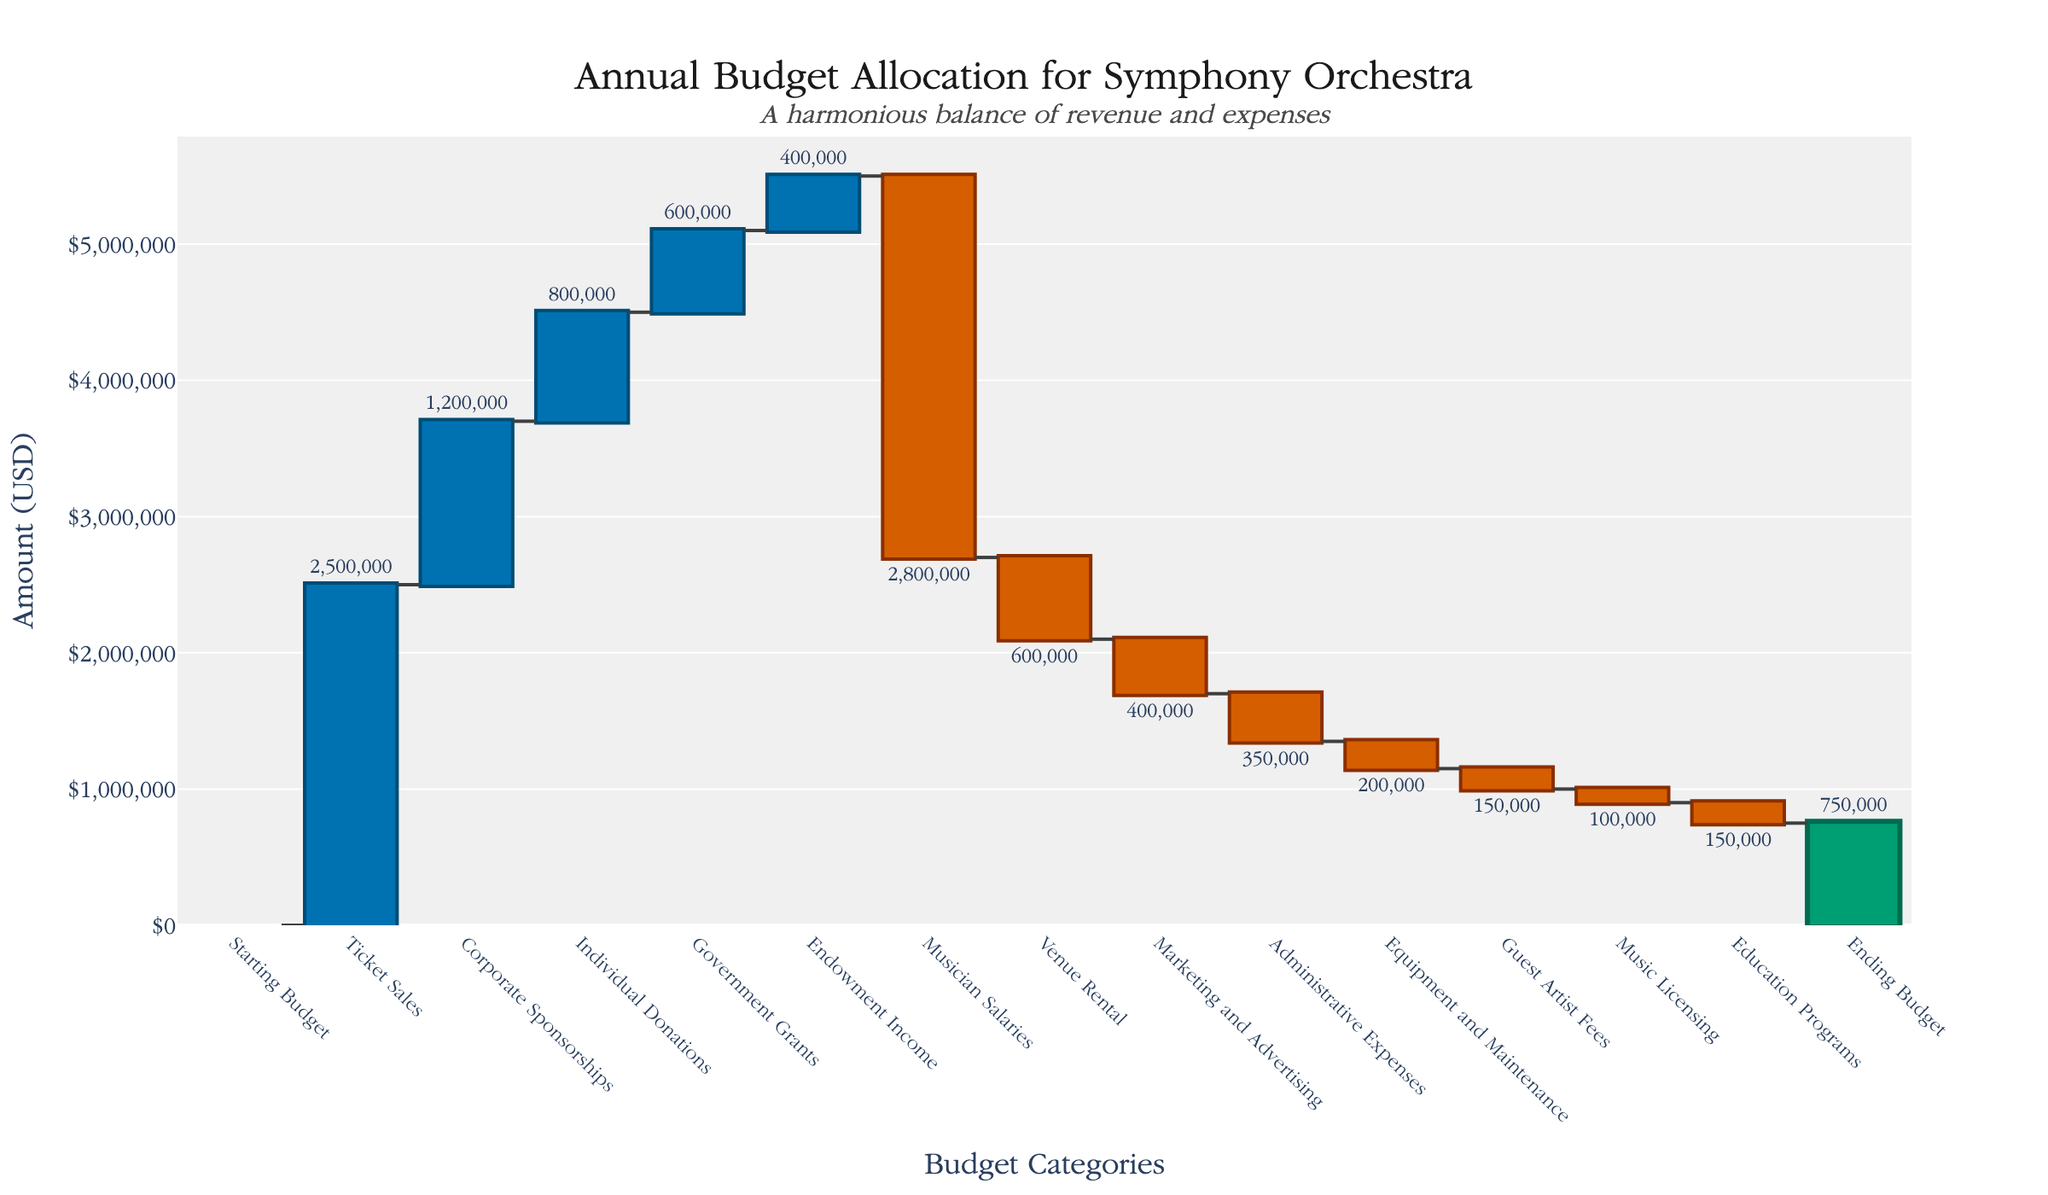What's the title of the figure? The title is prominently placed at the top of the figure, centered, and states "Annual Budget Allocation for Symphony Orchestra".
Answer: Annual Budget Allocation for Symphony Orchestra What is the value of the ending budget? Find the "Ending Budget" bar towards the end of the waterfall chart. The bar has a label indicating it is $750,000.
Answer: $750,000 Which category contributes the most to the revenue? Look at the categories labeled with positive values (blue bars) and compare their heights. The highest among them is "Ticket Sales" with $2,500,000.
Answer: Ticket Sales How much is the total revenue from all sources? Add up the positive contributions: Ticket Sales ($2,500,000) + Corporate Sponsorships ($1,200,000) + Individual Donations ($800,000) + Government Grants ($600,000) + Endowment Income ($400,000). This sums up to $5,500,000.
Answer: $5,500,000 What is the difference between the highest expense and the lowest expense? Identify the highest and lowest expenses from the negative values (red bars). The highest is "Musician Salaries" with $2,800,000 and the lowest is "Music Licensing" with $100,000. Subtract the two: $2,800,000 - $100,000 = $2,700,000.
Answer: $2,700,000 Which expense category is the smallest? Check the negative values (red bars) and identify the smallest value. The "Music Licensing" category has the smallest value of $100,000.
Answer: Music Licensing How much more is spent on Musician Salaries than on Marketing and Advertising? Find the bar values for "Musician Salaries" ($2,800,000) and "Marketing and Advertising" ($400,000). Subtract to find the difference: $2,800,000 - $400,000 = $2,400,000.
Answer: $2,400,000 What percentage of the total expenses is represented by the Venue Rental? Find the total expenses by adding all the negative values: Musician Salaries ($2,800,000) + Venue Rental ($600,000) + Marketing and Advertising ($400,000) + Administrative Expenses ($350,000) + Equipment and Maintenance ($200,000) + Guest Artist Fees ($150,000) + Music Licensing ($100,000) + Education Programs ($150,000) = $4,750,000. The Venue Rental is $600,000. Calculate: ($600,000 / $4,750,000) × 100 ≈ 12.63%.
Answer: ≈ 12.63% How does the budget allocation for Administrative Expenses compare to Equipment and Maintenance? Compare the two bars: Administrative Expenses is $350,000 and Equipment and Maintenance is $200,000. Administrative Expenses are higher.
Answer: Administrative Expenses are higher What are the two largest sources of revenue and by how much do they differ? The two largest sources of revenue are "Ticket Sales" ($2,500,000) and "Corporate Sponsorships" ($1,200,000). Subtract the two to find the difference: $2,500,000 - $1,200,000 = $1,300,000.
Answer: $1,300,000 What's the net revenue after accounting for "Ticket Sales" and "Corporate Sponsorships"? Add the amounts for "Ticket Sales" ($2,500,000) and "Corporate Sponsorships" ($1,200,000) and sum them up: $2,500,000 + $1,200,000 = $3,700,000.
Answer: $3,700,000 